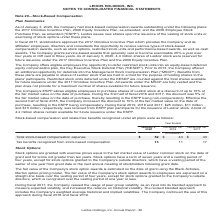According to Leidos Holdings's financial document, What was the 2017 Omnibus Incentive Plan? provides the Company and its affiliates' employees, directors and consultants the opportunity to receive various types of stock-based compensation awards, such as stock options, restricted stock units and performance-based awards, as well as cash awards.. The document states: "ers approved the 2017 Omnibus Incentive Plan which provides the Company and its affiliates' employees, directors and consultants the opportunity to re..." Also, What was the number of Leidos' stock were reserved for future issuance under the 2017 Omnibus Incentive Plan and the 2006 Equity Incentive Plan? According to the financial document, 4.4 million. The relevant text states: "cliff vest in three years. As of January 3, 2020, 4.4 million shares of Leidos' stock were reserved for future issuance under the 2017 Omnibus Incentive Plan and..." Also, What was the Total stock-based compensation expense in 2020, 2018 and 2017 respectively? The document contains multiple relevant values: $52, $44, $43 (in millions). From the document: "otal stock-based compensation expense $ 52 $ 44 $ 43 Tax benefits recognized from stock-based compensation 13 11 17 ns) Total stock-based compensation..." Additionally, In which year was Total stock-based compensation expense less than 50 million? The document shows two values: 2018 and 2017. Locate and analyze total stock-based compensation expense in row 5. From the document: "January 3, 2020 December 28, 2018 December 29, 2017 January 3, 2020 December 28, 2018 December 29, 2017..." Also, can you calculate: What was the average Total stock-based compensation expense in 2018 and 2017? To answer this question, I need to perform calculations using the financial data. The calculation is: (44 + 43) / 2, which equals 43.5 (in millions). This is based on the information: "otal stock-based compensation expense $ 52 $ 44 $ 43 Tax benefits recognized from stock-based compensation 13 11 17 ns) Total stock-based compensation expense $ 52 $ 44 $ 43 Tax benefits recognized fr..." The key data points involved are: 44. Also, can you calculate: What was the change in the Tax benefits recognized from stock-based compensation from 2017 to 2018? Based on the calculation: 11 - 17, the result is -6 (in millions). This is based on the information: "efits recognized from stock-based compensation 13 11 17 ts recognized from stock-based compensation 13 11 17..." The key data points involved are: 11, 17. 